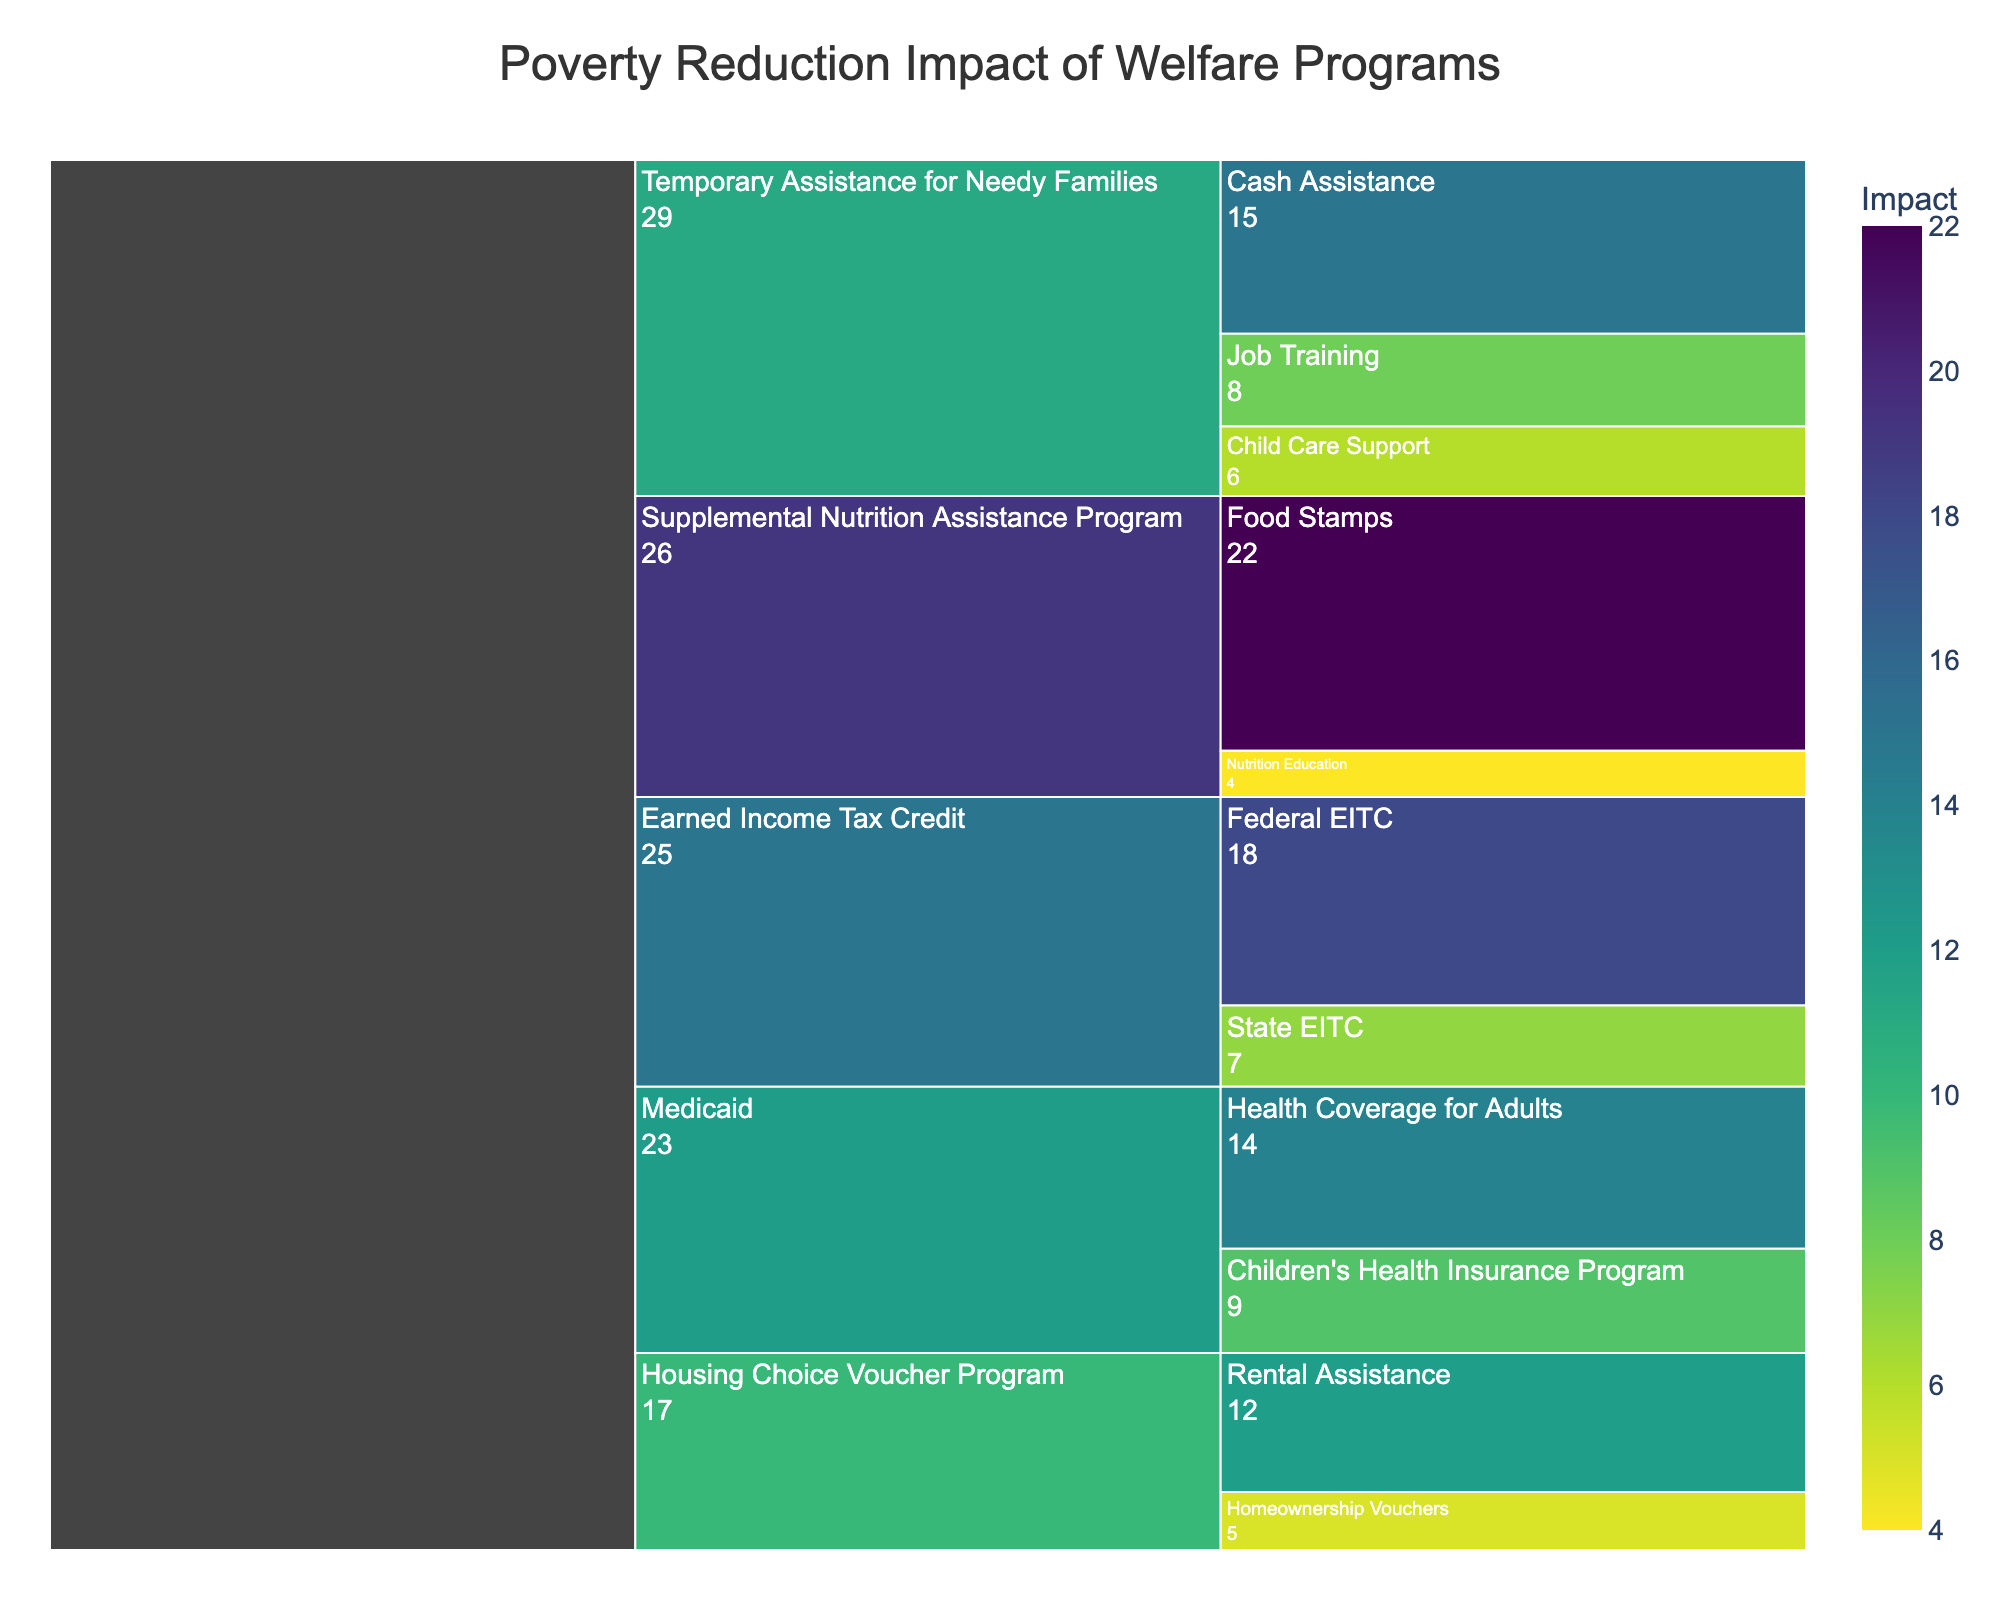What is the total impact of the Temporary Assistance for Needy Families program on poverty reduction? Sum the impacts of all sub-programs under Temporary Assistance for Needy Families: Cash Assistance (15), Job Training (8), and Child Care Support (6). 15 + 8 + 6 = 29
Answer: 29 Which program has the highest impact on poverty reduction? Identify the program with the largest total impact. Supplemental Nutrition Assistance Program has an impact of 22 (Food Stamps) + 4 (Nutrition Education) = 26, which exceeds the impacts of other programs.
Answer: Supplemental Nutrition Assistance Program What is the combined impact of Medicaid programs on poverty reduction? Add the impacts of Health Coverage for Adults (14) and Children's Health Insurance Program (9). 14 + 9 = 23
Answer: 23 Between the Earned Income Tax Credit and the Housing Choice Voucher Program, which has a higher total impact on poverty reduction? Calculate the total impact of Earned Income Tax Credit (Federal EITC 18 + State EITC 7 = 25) and compare it with the total impact of Housing Choice Voucher Program (Rental Assistance 12 + Homeownership Vouchers 5 = 17). 25 > 17
Answer: Earned Income Tax Credit Which sub-program in the Temporary Assistance for Needy Families program has the lowest impact on poverty reduction? Compare the impacts of sub-programs under Temporary Assistance for Needy Families: Cash Assistance (15), Job Training (8), and Child Care Support (6). The lowest is Child Care Support with 6.
Answer: Child Care Support How does the impact of Federal EITC compare to Health Coverage for Adults under Medicaid? Compare the impact values of Federal EITC (18) and Health Coverage for Adults (14). 18 > 14
Answer: Federal EITC has a higher impact than Health Coverage for Adults What is the average impact of all sub-programs under the Supplemental Nutrition Assistance Program? Add the impacts of Food Stamps (22) and Nutrition Education (4), then divide by the number of sub-programs. (22 + 4)/2 = 13
Answer: 13 Which Medicaid sub-program has a higher impact on poverty reduction, Health Coverage for Adults or the Children's Health Insurance Program? Compare the impact values of Health Coverage for Adults (14) and Children's Health Insurance Program (9). 14 > 9
Answer: Health Coverage for Adults What is the difference in impact between the highest and lowest impact sub-programs within the Earned Income Tax Credit program? Subtract the impact of the State EITC (7) from the Federal EITC (18). 18 - 7 = 11
Answer: 11 